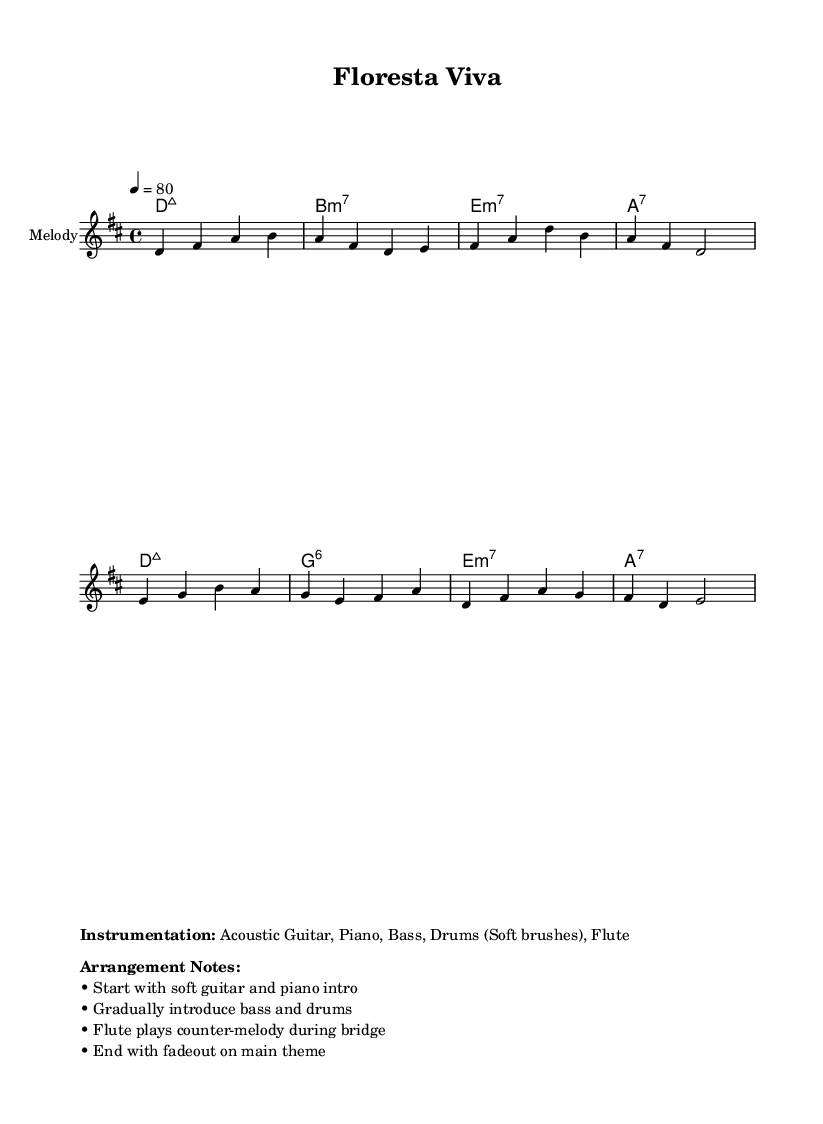What is the key signature of this music? The key signature is indicated by the '#' symbol on the staff, which signifies that there are two sharps (F# and C#). This corresponds to the key of D major.
Answer: D major What is the time signature of this music? The time signature is shown at the beginning of the sheet music as 4/4, which means there are four beats per measure and a quarter note receives one beat.
Answer: 4/4 What is the tempo marking for this piece? The tempo is indicated at the beginning, marked as "4 = 80," meaning there should be 80 beats per minute, counted as quarter notes.
Answer: 80 How many measures are in the melody? By counting the number of bars in the melody staff, there are a total of 8 measures. Each bar corresponds to a measure in musical notation.
Answer: 8 What is the first chord in the harmony section? The first chord is indicated in the chord symbols above the staff and is labeled as "D:maj7," meaning a D major seventh chord.
Answer: D:maj7 What instruments are specified for this arrangement? The instrumentation is listed in the markup section, specifying that the music includes Acoustic Guitar, Piano, Bass, Drums (Soft brushes), and Flute.
Answer: Acoustic Guitar, Piano, Bass, Drums (Soft brushes), Flute What thematic element does the lyrics focus on? The lyrics emphasize nature's beauty and harmony, as indicated by phrases like "Ver de florest," which translates to "Seeing the forest," and highlight themes of preservation.
Answer: Nature conservation 